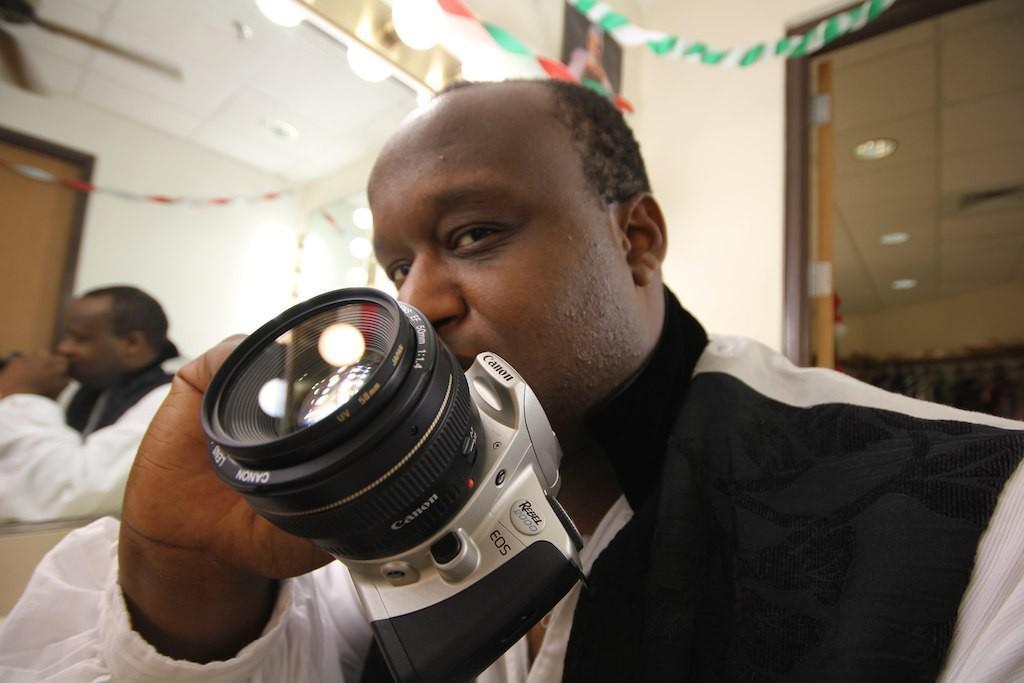In one or two sentences, can you explain what this image depicts? In the image we can see there is a person who is holding a camera in his hand. In the back the wall is in cream colour and beside the person there is another person sitting. 